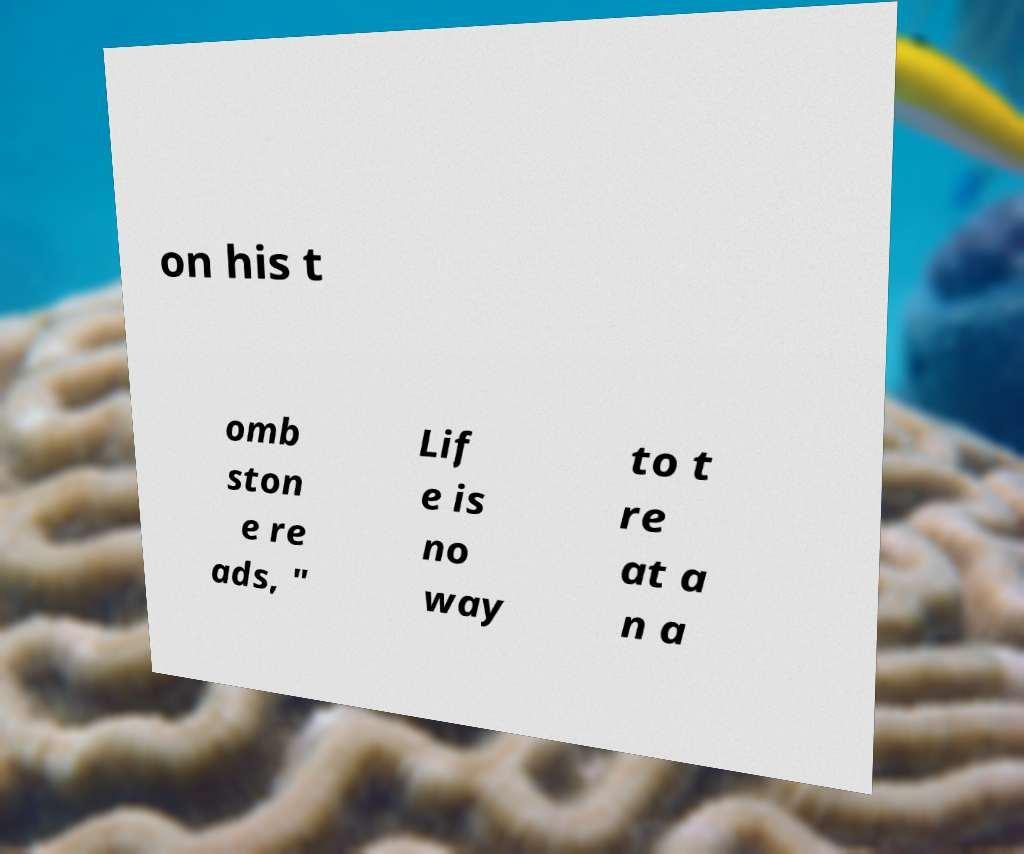There's text embedded in this image that I need extracted. Can you transcribe it verbatim? on his t omb ston e re ads, " Lif e is no way to t re at a n a 